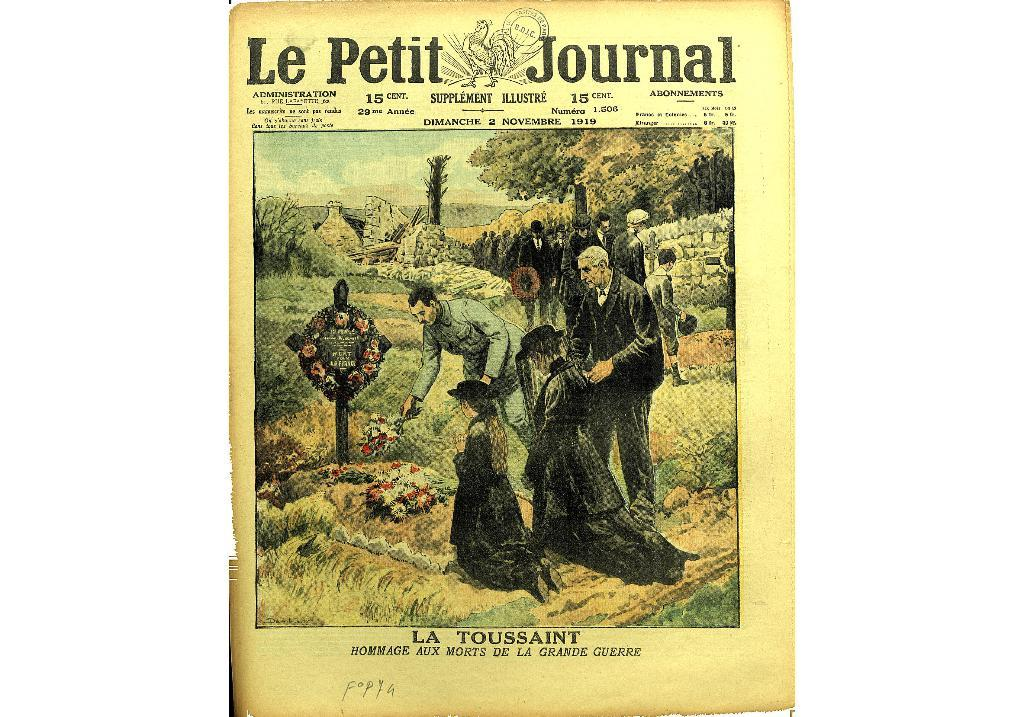<image>
Relay a brief, clear account of the picture shown. a page that says 'le petit journal' at the top of it 